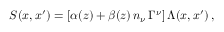Convert formula to latex. <formula><loc_0><loc_0><loc_500><loc_500>S ( x , x ^ { \prime } ) = [ \alpha ( z ) + \beta ( z ) \, n _ { \nu } \, \Gamma ^ { \nu } ] \, \Lambda ( x , x ^ { \prime } ) \, ,</formula> 